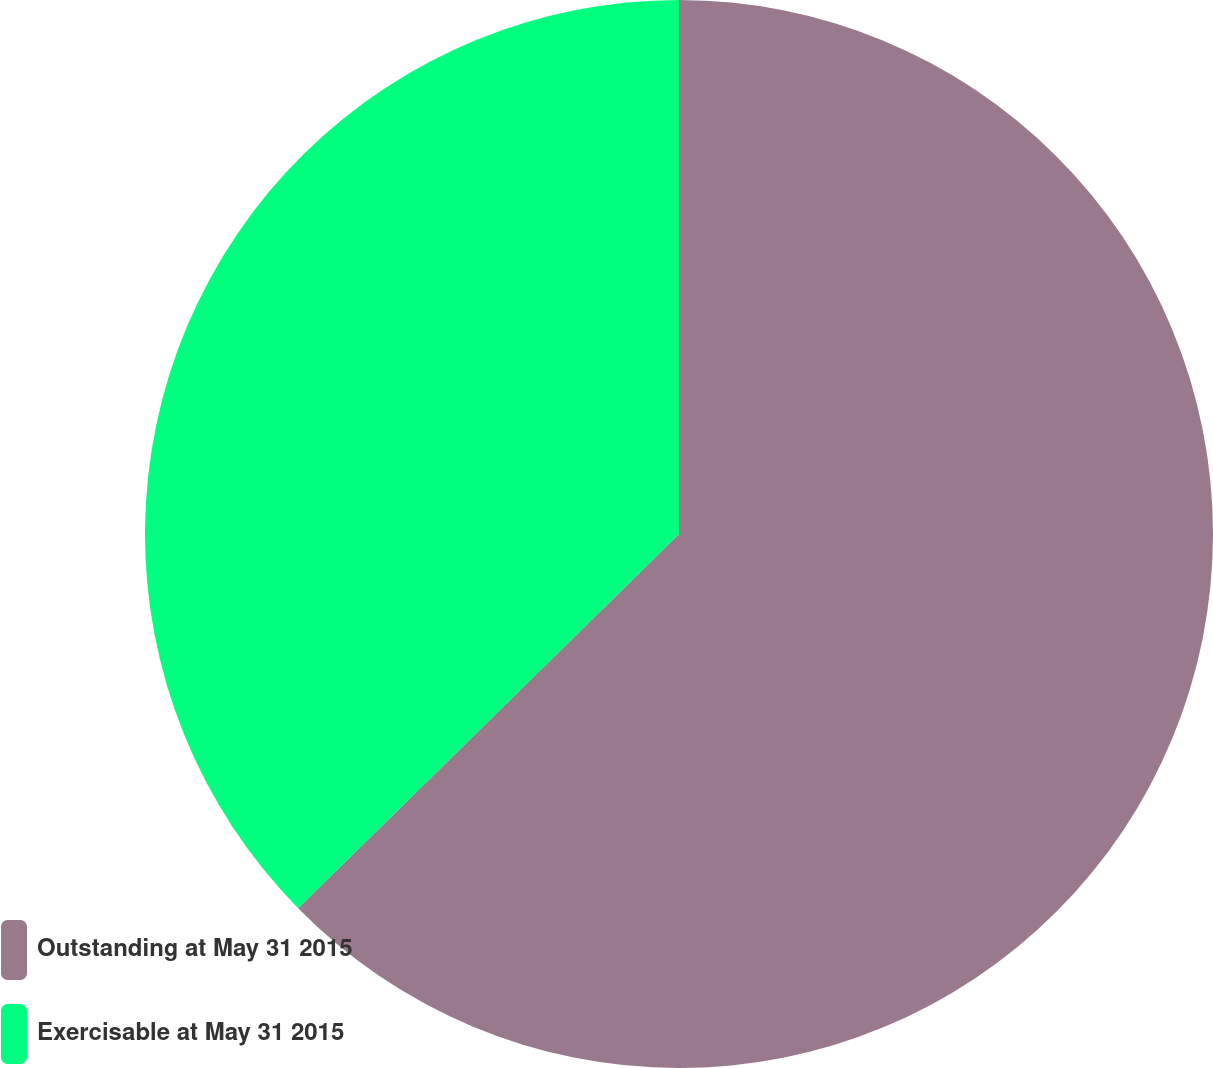<chart> <loc_0><loc_0><loc_500><loc_500><pie_chart><fcel>Outstanding at May 31 2015<fcel>Exercisable at May 31 2015<nl><fcel>62.64%<fcel>37.36%<nl></chart> 